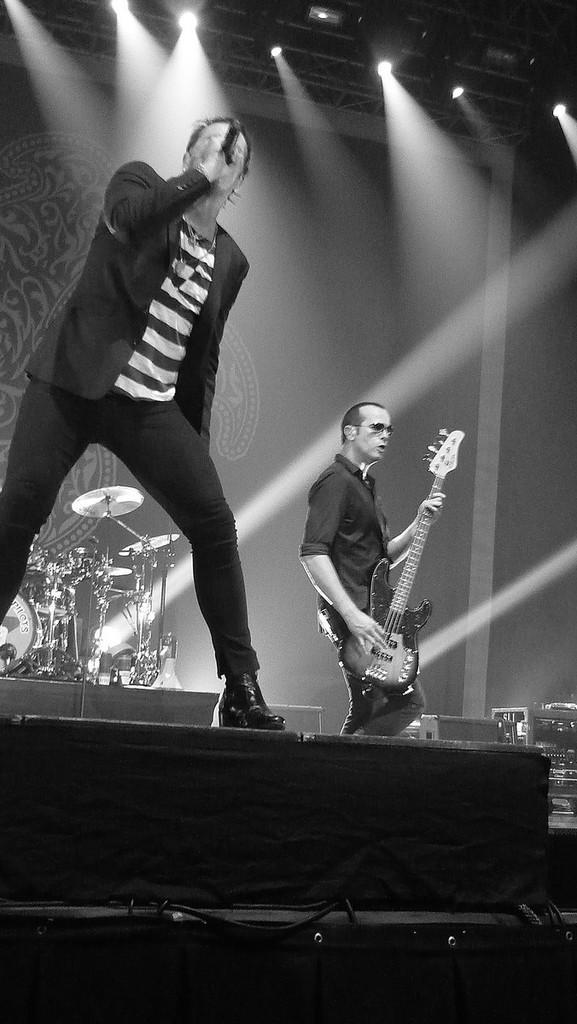Describe this image in one or two sentences. There are two men on the stage. One man is playing a guitar and the other is singing a song and holding a mic in his hand. In the background there are some musical instruments like drums. On the top there are some lights. 